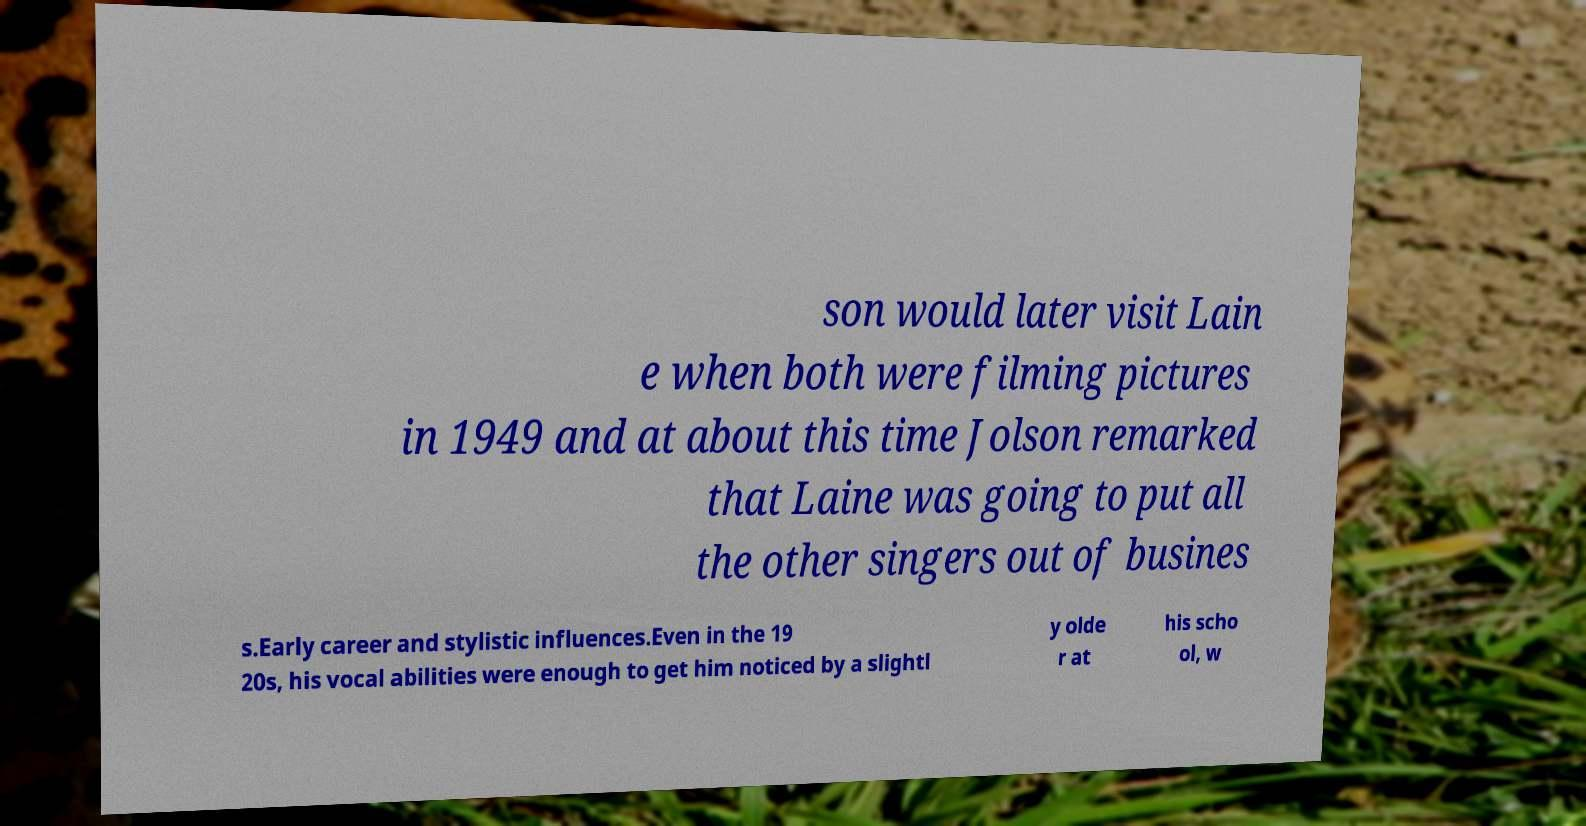Could you assist in decoding the text presented in this image and type it out clearly? son would later visit Lain e when both were filming pictures in 1949 and at about this time Jolson remarked that Laine was going to put all the other singers out of busines s.Early career and stylistic influences.Even in the 19 20s, his vocal abilities were enough to get him noticed by a slightl y olde r at his scho ol, w 